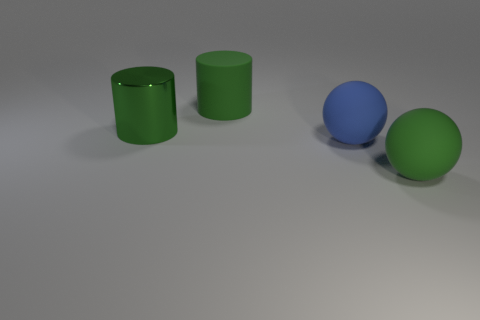Add 2 small green things. How many objects exist? 6 Subtract all cylinders. Subtract all large metal things. How many objects are left? 1 Add 1 large green cylinders. How many large green cylinders are left? 3 Add 3 blue shiny cylinders. How many blue shiny cylinders exist? 3 Subtract 0 purple cylinders. How many objects are left? 4 